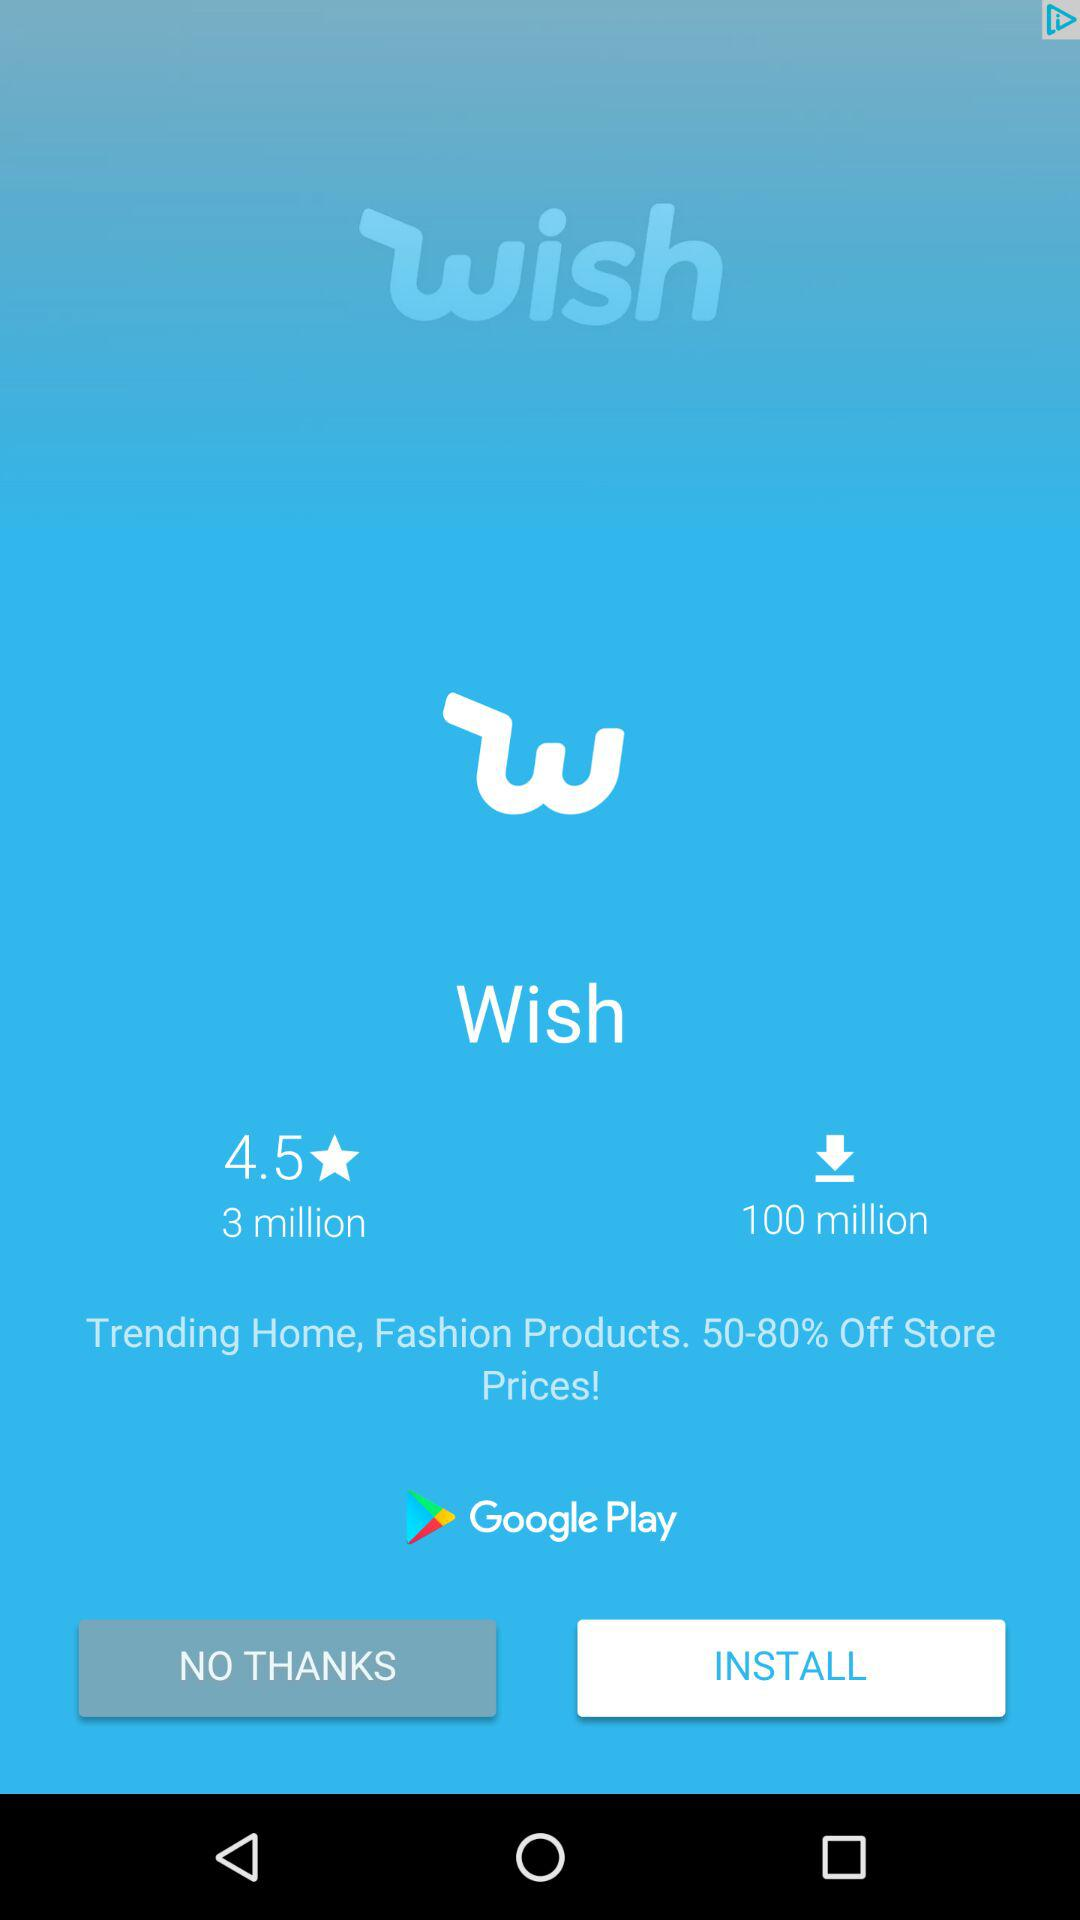How many more downloads does the Wish app have than the number of reviews?
Answer the question using a single word or phrase. 97 million 